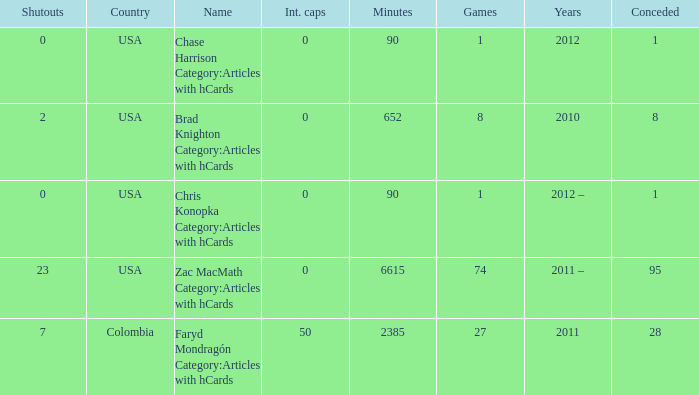When 2010 is the year what is the game? 8.0. 